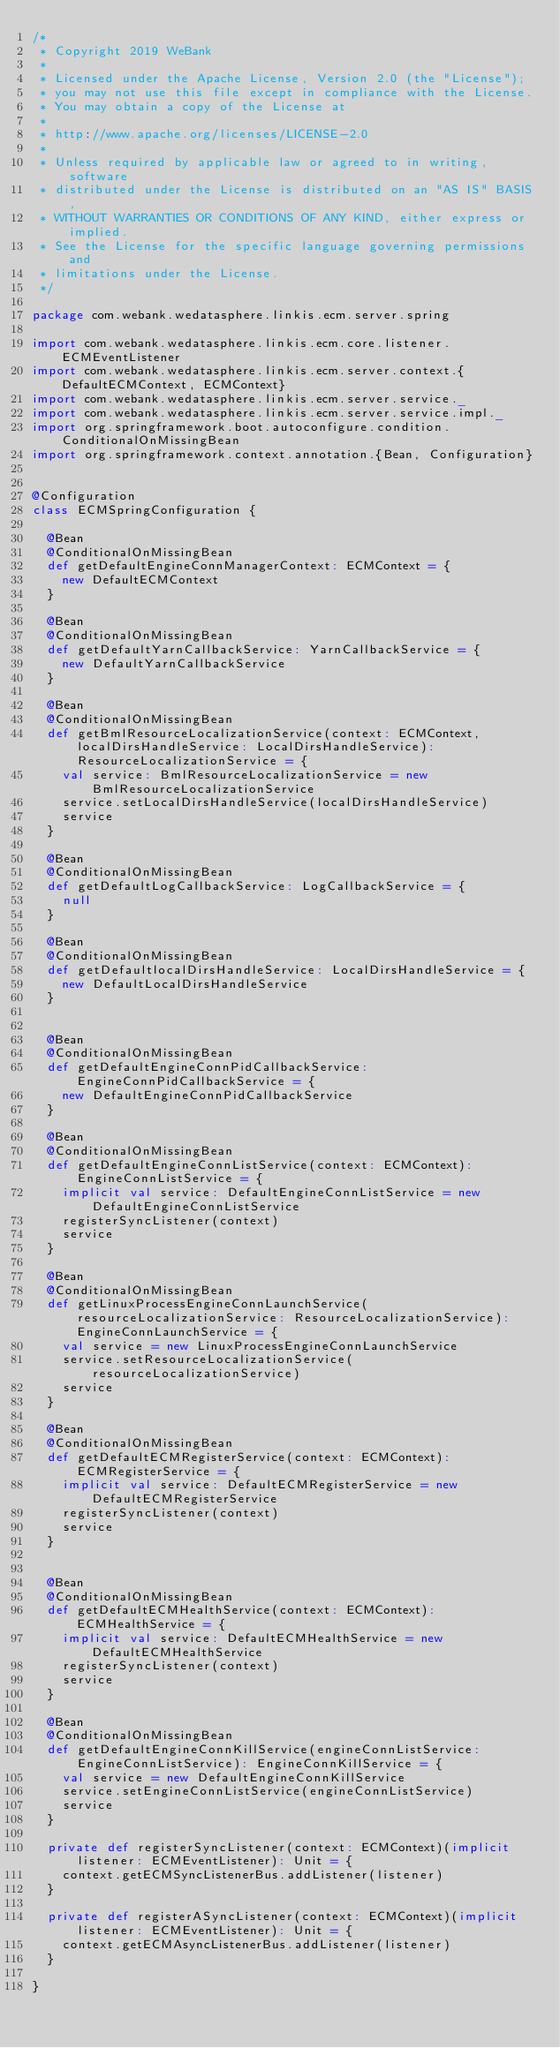Convert code to text. <code><loc_0><loc_0><loc_500><loc_500><_Scala_>/*
 * Copyright 2019 WeBank
 *
 * Licensed under the Apache License, Version 2.0 (the "License");
 * you may not use this file except in compliance with the License.
 * You may obtain a copy of the License at
 *
 * http://www.apache.org/licenses/LICENSE-2.0
 *
 * Unless required by applicable law or agreed to in writing, software
 * distributed under the License is distributed on an "AS IS" BASIS,
 * WITHOUT WARRANTIES OR CONDITIONS OF ANY KIND, either express or implied.
 * See the License for the specific language governing permissions and
 * limitations under the License.
 */

package com.webank.wedatasphere.linkis.ecm.server.spring

import com.webank.wedatasphere.linkis.ecm.core.listener.ECMEventListener
import com.webank.wedatasphere.linkis.ecm.server.context.{DefaultECMContext, ECMContext}
import com.webank.wedatasphere.linkis.ecm.server.service._
import com.webank.wedatasphere.linkis.ecm.server.service.impl._
import org.springframework.boot.autoconfigure.condition.ConditionalOnMissingBean
import org.springframework.context.annotation.{Bean, Configuration}


@Configuration
class ECMSpringConfiguration {

  @Bean
  @ConditionalOnMissingBean
  def getDefaultEngineConnManagerContext: ECMContext = {
    new DefaultECMContext
  }

  @Bean
  @ConditionalOnMissingBean
  def getDefaultYarnCallbackService: YarnCallbackService = {
    new DefaultYarnCallbackService
  }

  @Bean
  @ConditionalOnMissingBean
  def getBmlResourceLocalizationService(context: ECMContext, localDirsHandleService: LocalDirsHandleService): ResourceLocalizationService = {
    val service: BmlResourceLocalizationService = new BmlResourceLocalizationService
    service.setLocalDirsHandleService(localDirsHandleService)
    service
  }

  @Bean
  @ConditionalOnMissingBean
  def getDefaultLogCallbackService: LogCallbackService = {
    null
  }

  @Bean
  @ConditionalOnMissingBean
  def getDefaultlocalDirsHandleService: LocalDirsHandleService = {
    new DefaultLocalDirsHandleService
  }


  @Bean
  @ConditionalOnMissingBean
  def getDefaultEngineConnPidCallbackService: EngineConnPidCallbackService = {
    new DefaultEngineConnPidCallbackService
  }

  @Bean
  @ConditionalOnMissingBean
  def getDefaultEngineConnListService(context: ECMContext): EngineConnListService = {
    implicit val service: DefaultEngineConnListService = new DefaultEngineConnListService
    registerSyncListener(context)
    service
  }

  @Bean
  @ConditionalOnMissingBean
  def getLinuxProcessEngineConnLaunchService(resourceLocalizationService: ResourceLocalizationService): EngineConnLaunchService = {
    val service = new LinuxProcessEngineConnLaunchService
    service.setResourceLocalizationService(resourceLocalizationService)
    service
  }

  @Bean
  @ConditionalOnMissingBean
  def getDefaultECMRegisterService(context: ECMContext): ECMRegisterService = {
    implicit val service: DefaultECMRegisterService = new DefaultECMRegisterService
    registerSyncListener(context)
    service
  }


  @Bean
  @ConditionalOnMissingBean
  def getDefaultECMHealthService(context: ECMContext): ECMHealthService = {
    implicit val service: DefaultECMHealthService = new DefaultECMHealthService
    registerSyncListener(context)
    service
  }

  @Bean
  @ConditionalOnMissingBean
  def getDefaultEngineConnKillService(engineConnListService: EngineConnListService): EngineConnKillService = {
    val service = new DefaultEngineConnKillService
    service.setEngineConnListService(engineConnListService)
    service
  }

  private def registerSyncListener(context: ECMContext)(implicit listener: ECMEventListener): Unit = {
    context.getECMSyncListenerBus.addListener(listener)
  }

  private def registerASyncListener(context: ECMContext)(implicit listener: ECMEventListener): Unit = {
    context.getECMAsyncListenerBus.addListener(listener)
  }

}
</code> 